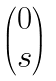<formula> <loc_0><loc_0><loc_500><loc_500>\begin{pmatrix} 0 \\ s \end{pmatrix}</formula> 